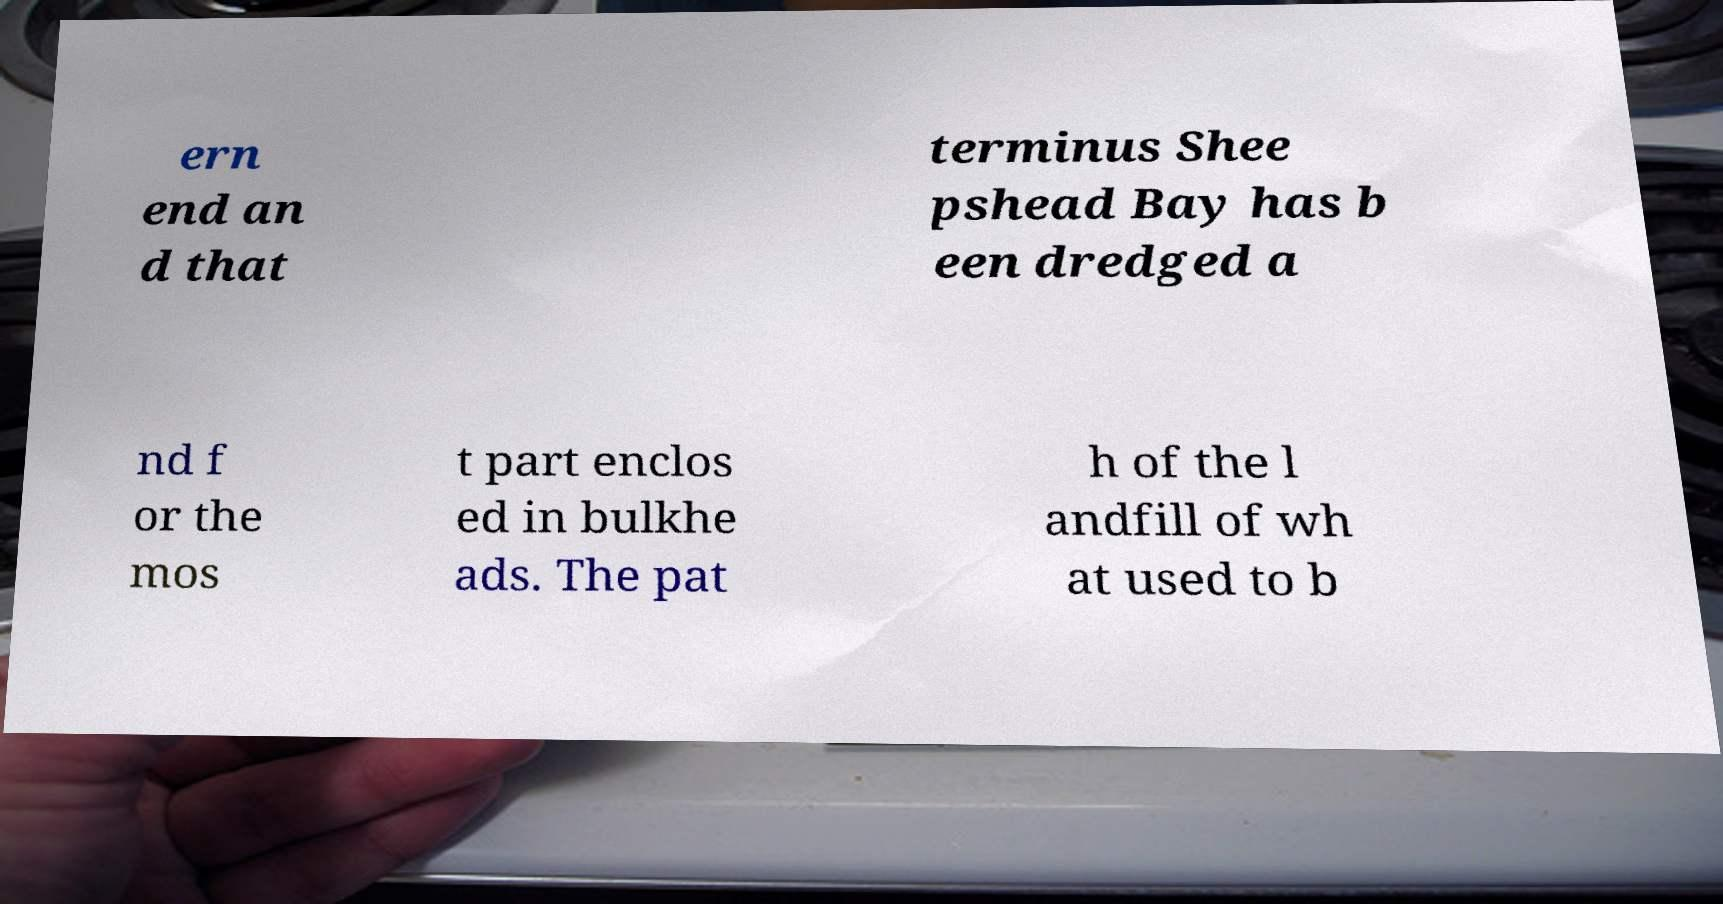Please identify and transcribe the text found in this image. ern end an d that terminus Shee pshead Bay has b een dredged a nd f or the mos t part enclos ed in bulkhe ads. The pat h of the l andfill of wh at used to b 